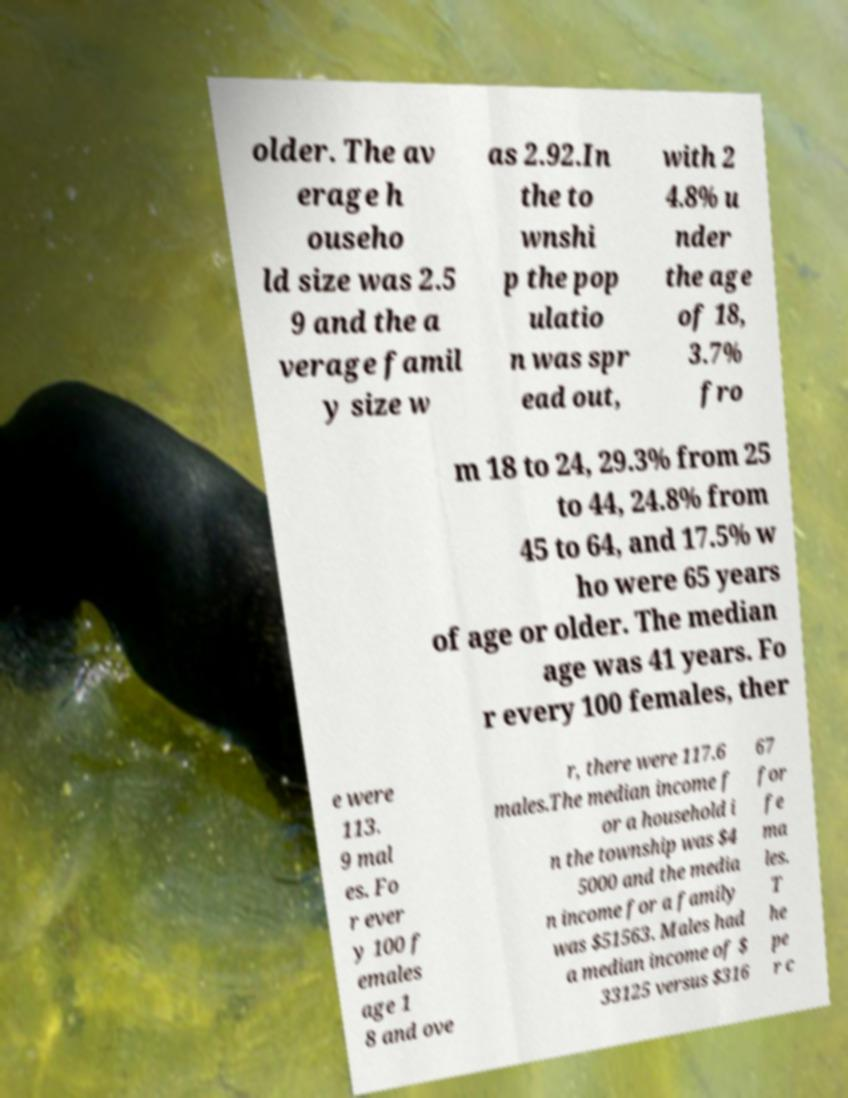I need the written content from this picture converted into text. Can you do that? older. The av erage h ouseho ld size was 2.5 9 and the a verage famil y size w as 2.92.In the to wnshi p the pop ulatio n was spr ead out, with 2 4.8% u nder the age of 18, 3.7% fro m 18 to 24, 29.3% from 25 to 44, 24.8% from 45 to 64, and 17.5% w ho were 65 years of age or older. The median age was 41 years. Fo r every 100 females, ther e were 113. 9 mal es. Fo r ever y 100 f emales age 1 8 and ove r, there were 117.6 males.The median income f or a household i n the township was $4 5000 and the media n income for a family was $51563. Males had a median income of $ 33125 versus $316 67 for fe ma les. T he pe r c 